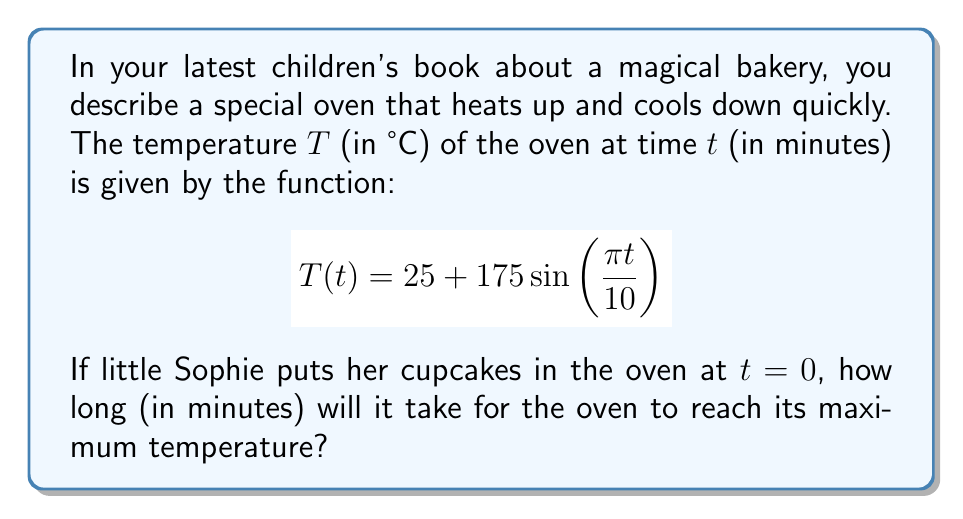Help me with this question. Let's approach this step-by-step:

1) The temperature function is a sine wave with some modifications. The general form of a sine function is:

   $$f(t) = A \sin(Bt) + C$$

   Where $A$ is the amplitude, $B$ is the angular frequency, and $C$ is the vertical shift.

2) In our case:
   - $A = 175$ (amplitude)
   - $B = \frac{\pi}{10}$ (angular frequency)
   - $C = 25$ (vertical shift)

3) The sine function reaches its maximum value when its argument equals $\frac{\pi}{2}$ (or 90°).

4) So, we need to solve:

   $$\frac{\pi t}{10} = \frac{\pi}{2}$$

5) Simplifying:

   $$t = 5$$

6) This means the oven reaches its maximum temperature 5 minutes after Sophie puts her cupcakes in.

7) To verify, we can calculate:
   
   $$T(5) = 25 + 175 \sin\left(\frac{\pi \cdot 5}{10}\right) = 25 + 175 = 200°C$$

   This is indeed the maximum temperature, as $\sin(\frac{\pi}{2}) = 1$.
Answer: 5 minutes 